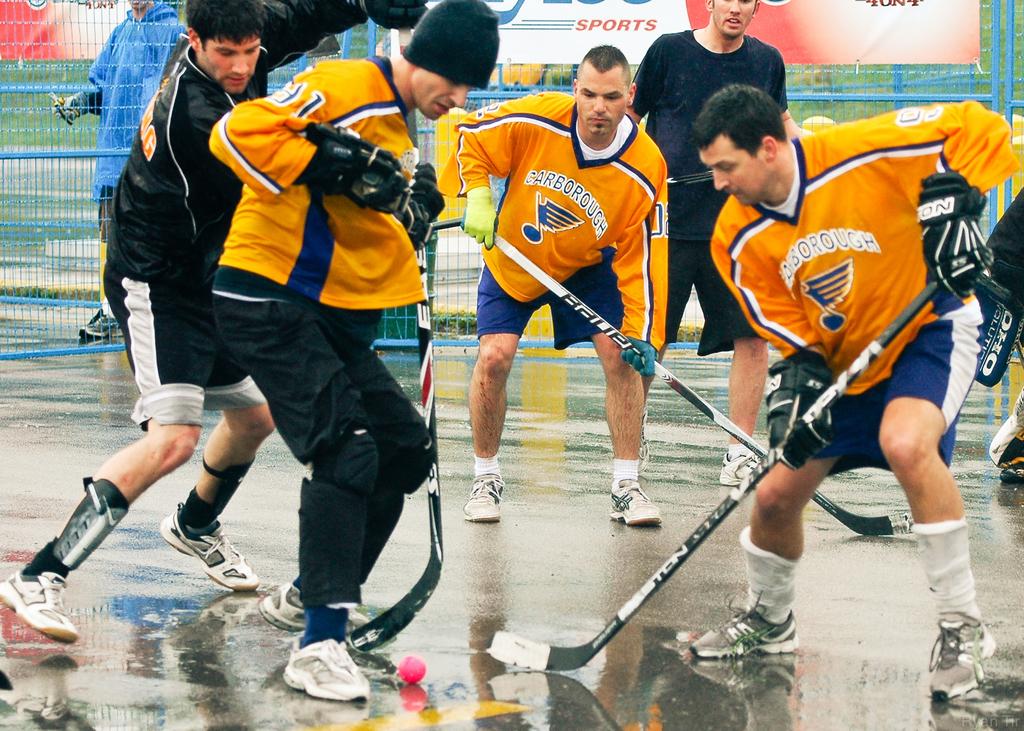What is the name of the hockey team?
Provide a short and direct response. Carborough. What brand is one of the hockey sticks?
Provide a succinct answer. Bauer. 